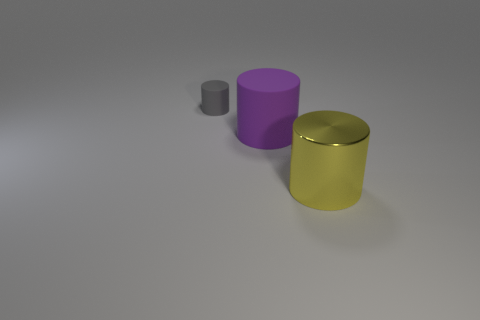Add 2 big things. How many objects exist? 5 Add 3 large yellow objects. How many large yellow objects are left? 4 Add 1 small cyan metal cylinders. How many small cyan metal cylinders exist? 1 Subtract 1 purple cylinders. How many objects are left? 2 Subtract all large blue cubes. Subtract all large purple matte cylinders. How many objects are left? 2 